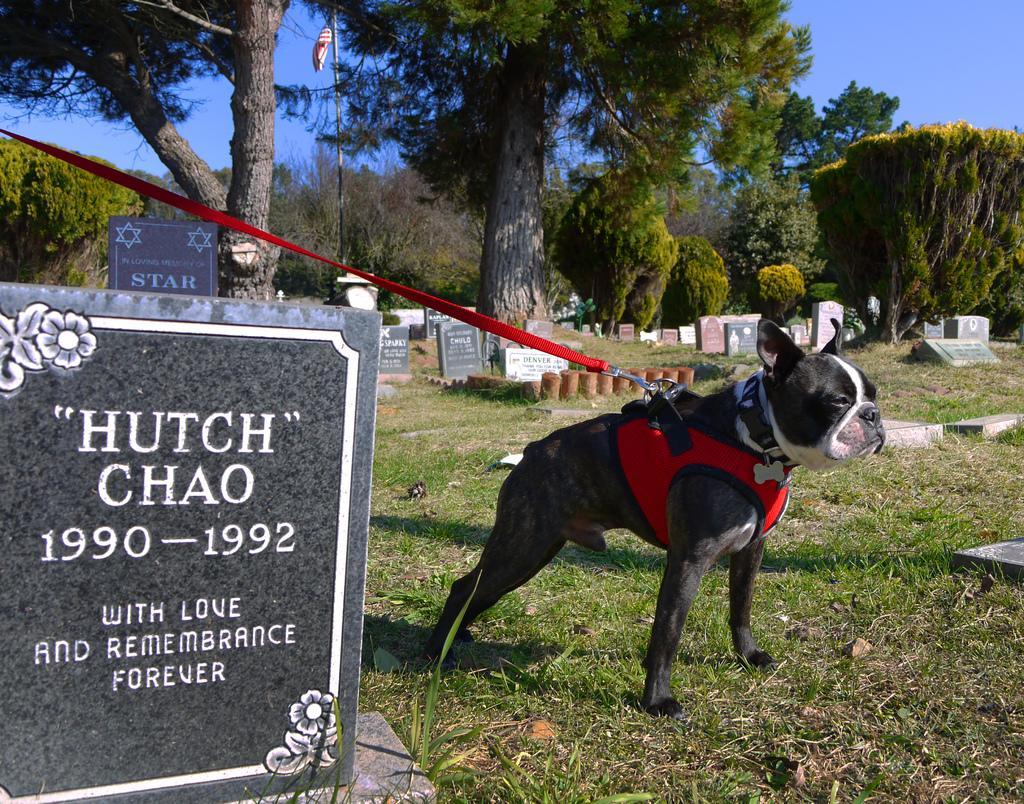Describe this image in one or two sentences. This image is taken outdoor. At the bottom of the image there is a ground with grass on it. At the top of image there is the sky. In the background there are many trees and plants on the ground and there is a flag. There are a few tombstones on the ground. In the middle of the image there is a dog with a belt around the neck. On the left side of the image there is a tombstone with a text on it. 